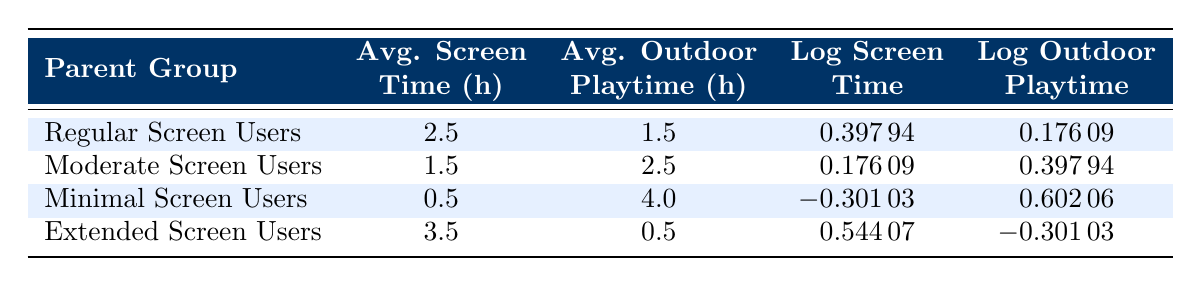What is the average screen time for Minimal Screen Users? The average screen time for Minimal Screen Users is directly listed in the table under the "Avg. Screen Time (h)" column for that group, which shows 0.5 hours.
Answer: 0.5 hours What is the average outdoor playtime for Regular Screen Users? The average outdoor playtime for Regular Screen Users is found in the table under the "Avg. Outdoor Playtime (h)" column, showing 1.5 hours.
Answer: 1.5 hours Is the average outdoor playtime for Extended Screen Users greater than that of Moderate Screen Users? The average outdoor playtime for Extended Screen Users is 0.5 hours, and for Moderate Screen Users, it is 2.5 hours. Since 0.5 is not greater than 2.5, the statement is false.
Answer: No What is the total screen time for Regular and Moderate Screen Users combined? The average screen time for Regular Screen Users is 2.5 hours, and for Moderate Screen Users, it is 1.5 hours. Adding these together gives 2.5 + 1.5 = 4.0 hours.
Answer: 4.0 hours Which parent group has the highest average screen time? By looking at the table, the Extended Screen Users have an average screen time of 3.5 hours, which is higher than all other groups.
Answer: Extended Screen Users How much more outdoor playtime do Minimal Screen Users have compared to Regular Screen Users? The average outdoor playtime for Minimal Screen Users is 4.0 hours while for Regular Screen Users it is 1.5 hours. Subtracting these gives 4.0 - 1.5 = 2.5 hours.
Answer: 2.5 hours Is it true that Moderate Screen Users have more outdoor playtime than Regular Screen Users? The average outdoor playtime for Moderate Screen Users is 2.5 hours and for Regular Screen Users, it is 1.5 hours. Since 2.5 is greater than 1.5, the statement is true.
Answer: Yes What is the log value of average screen time for Extended Screen Users? The log value of average screen time for Extended Screen Users is found in the "Log Screen Time" column, which indicates a value of 0.54407.
Answer: 0.54407 What is the average of average outdoor playtimes for all the parent groups? The average outdoor playtime can be calculated by taking the sum of all the outdoor playtimes: 1.5 + 2.5 + 4.0 + 0.5 = 8.5 hours. Dividing by 4 groups gives 8.5 / 4 = 2.125 hours.
Answer: 2.125 hours 